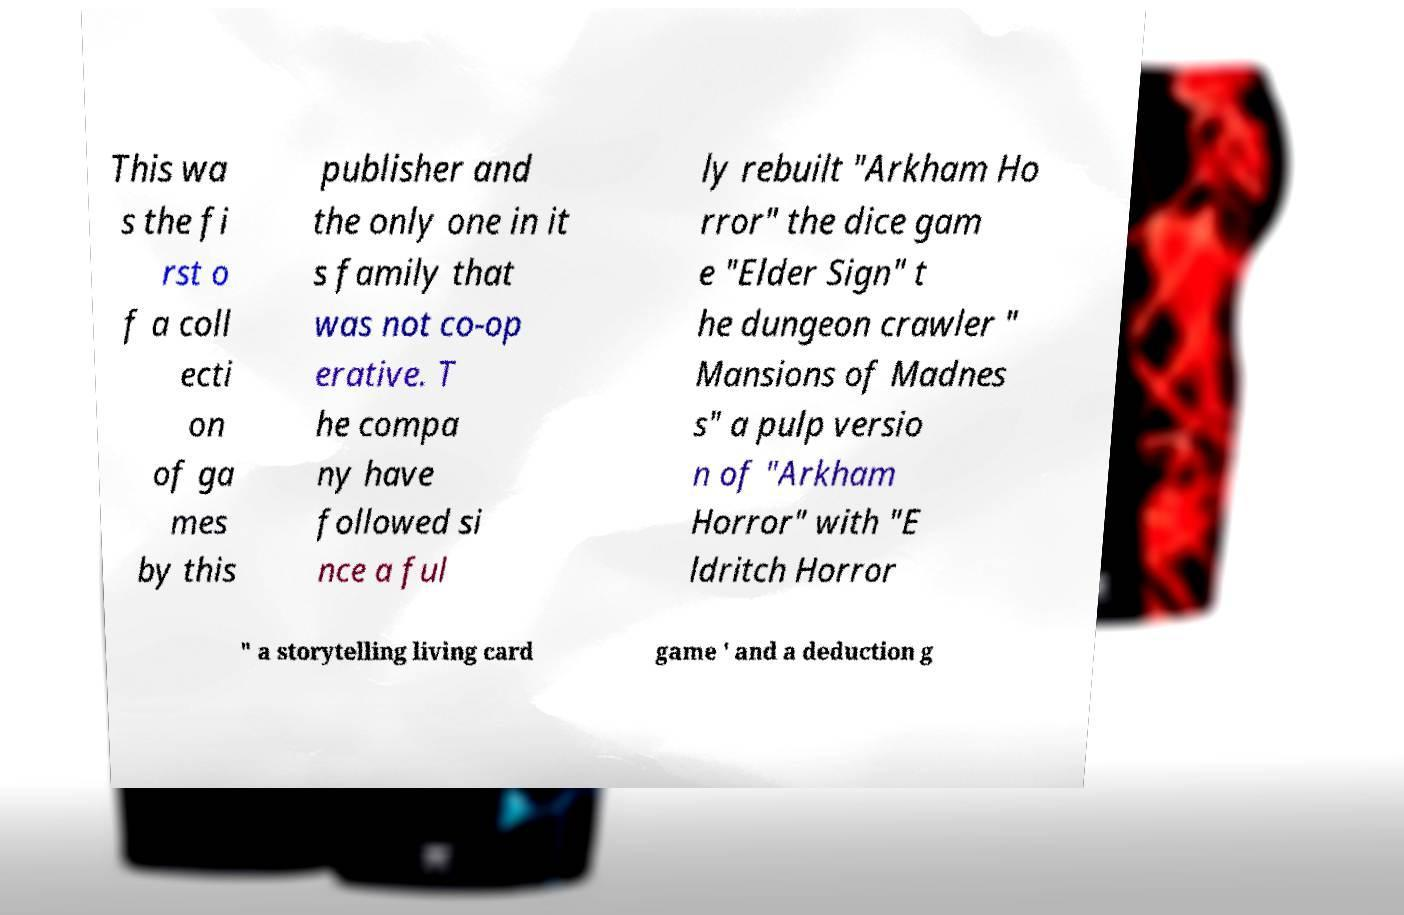There's text embedded in this image that I need extracted. Can you transcribe it verbatim? This wa s the fi rst o f a coll ecti on of ga mes by this publisher and the only one in it s family that was not co-op erative. T he compa ny have followed si nce a ful ly rebuilt "Arkham Ho rror" the dice gam e "Elder Sign" t he dungeon crawler " Mansions of Madnes s" a pulp versio n of "Arkham Horror" with "E ldritch Horror " a storytelling living card game ' and a deduction g 